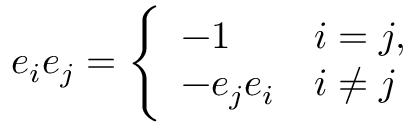<formula> <loc_0><loc_0><loc_500><loc_500>e _ { i } e _ { j } = { \Big \{ } { \begin{array} { l l } { - 1 } & { i = j , } \\ { - e _ { j } e _ { i } } & { i \not = j } \end{array} }</formula> 